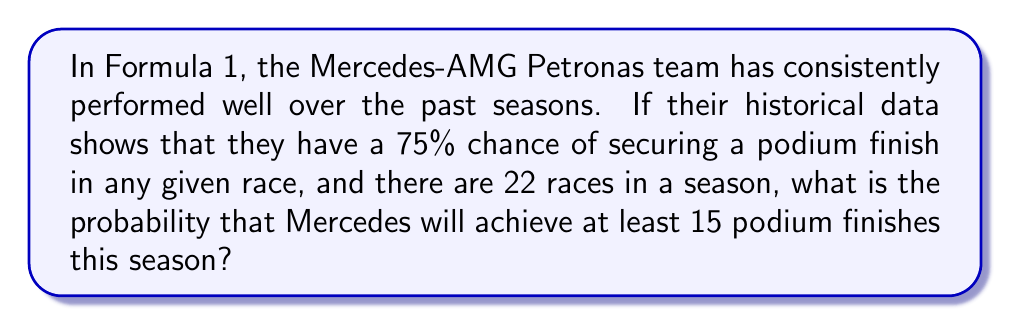Teach me how to tackle this problem. To solve this problem, we need to use the binomial probability distribution. Let's break it down step by step:

1) We can model this scenario as a binomial distribution with the following parameters:
   $n = 22$ (number of races)
   $p = 0.75$ (probability of a podium finish in a single race)
   $X$ = number of podium finishes (random variable)

2) We want to find $P(X \geq 15)$, which is equivalent to $1 - P(X \leq 14)$

3) The probability mass function for a binomial distribution is:

   $$P(X = k) = \binom{n}{k} p^k (1-p)^{n-k}$$

4) We need to sum this for all values from 0 to 14:

   $$P(X \leq 14) = \sum_{k=0}^{14} \binom{22}{k} (0.75)^k (0.25)^{22-k}$$

5) This sum is complex to calculate by hand, so we typically use statistical software or tables. Using a calculator or computer, we find:

   $P(X \leq 14) \approx 0.0388$

6) Therefore, the probability of at least 15 podium finishes is:

   $$P(X \geq 15) = 1 - P(X \leq 14) = 1 - 0.0388 = 0.9612$$

Thus, there is approximately a 96.12% chance that Mercedes will achieve at least 15 podium finishes in the season.
Answer: 0.9612 or 96.12% 